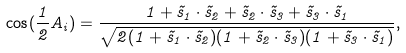<formula> <loc_0><loc_0><loc_500><loc_500>\cos ( \frac { 1 } { 2 } A _ { i } ) = \frac { 1 + \vec { s } _ { 1 } \cdot \vec { s } _ { 2 } + \vec { s } _ { 2 } \cdot \vec { s } _ { 3 } + \vec { s } _ { 3 } \cdot \vec { s } _ { 1 } } { \sqrt { 2 ( 1 + \vec { s } _ { 1 } \cdot \vec { s } _ { 2 } ) ( 1 + \vec { s } _ { 2 } \cdot \vec { s } _ { 3 } ) ( 1 + \vec { s } _ { 3 } \cdot \vec { s } _ { 1 } ) } } ,</formula> 